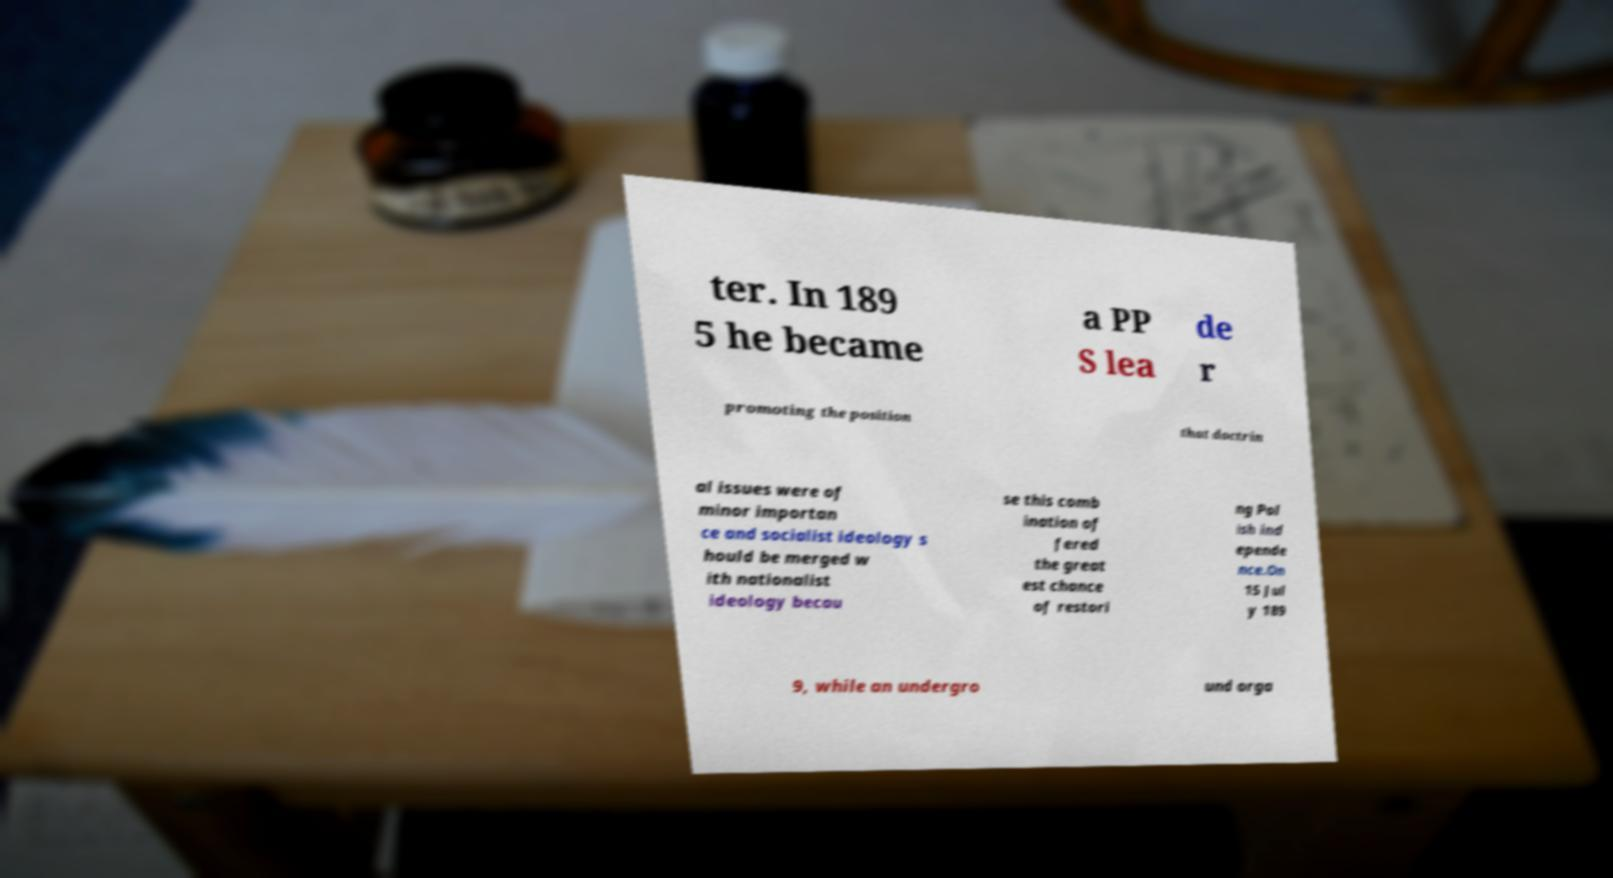Can you read and provide the text displayed in the image?This photo seems to have some interesting text. Can you extract and type it out for me? ter. In 189 5 he became a PP S lea de r promoting the position that doctrin al issues were of minor importan ce and socialist ideology s hould be merged w ith nationalist ideology becau se this comb ination of fered the great est chance of restori ng Pol ish ind epende nce.On 15 Jul y 189 9, while an undergro und orga 